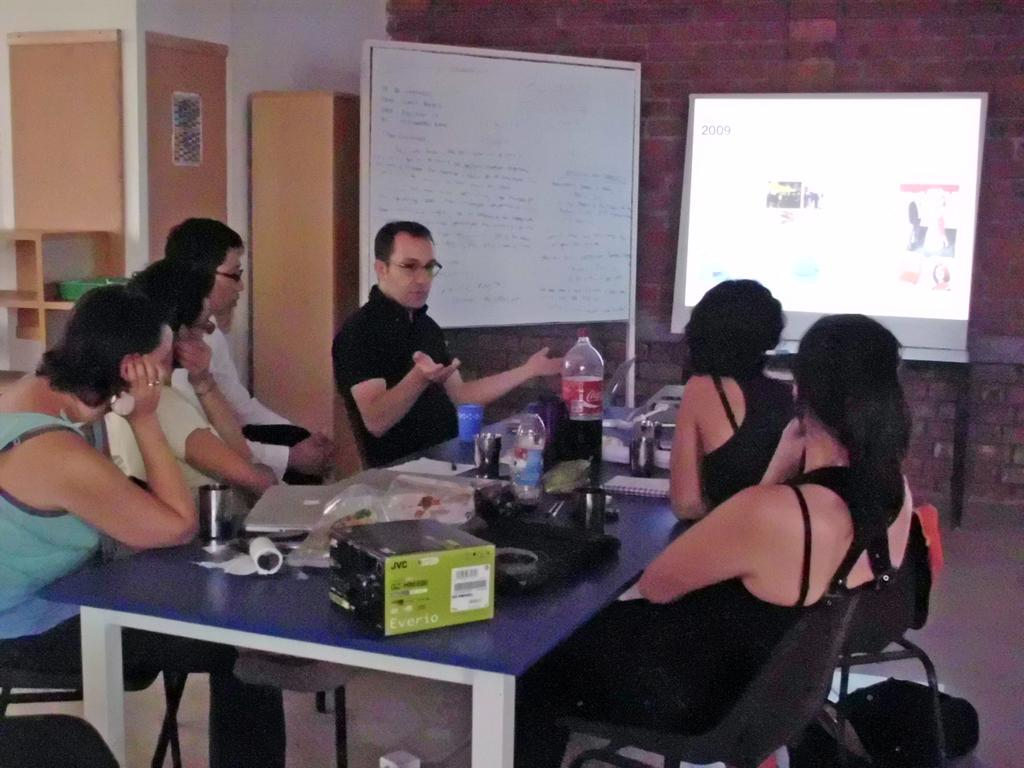Who or what can be seen in the image? There are people in the image. What are the people doing in the image? The people are sitting on chairs. What is in front of the people? There is a table in front of the people. What type of secretary is present in the image? There is no secretary present in the image; it only features people sitting on chairs with a table in front of them. 